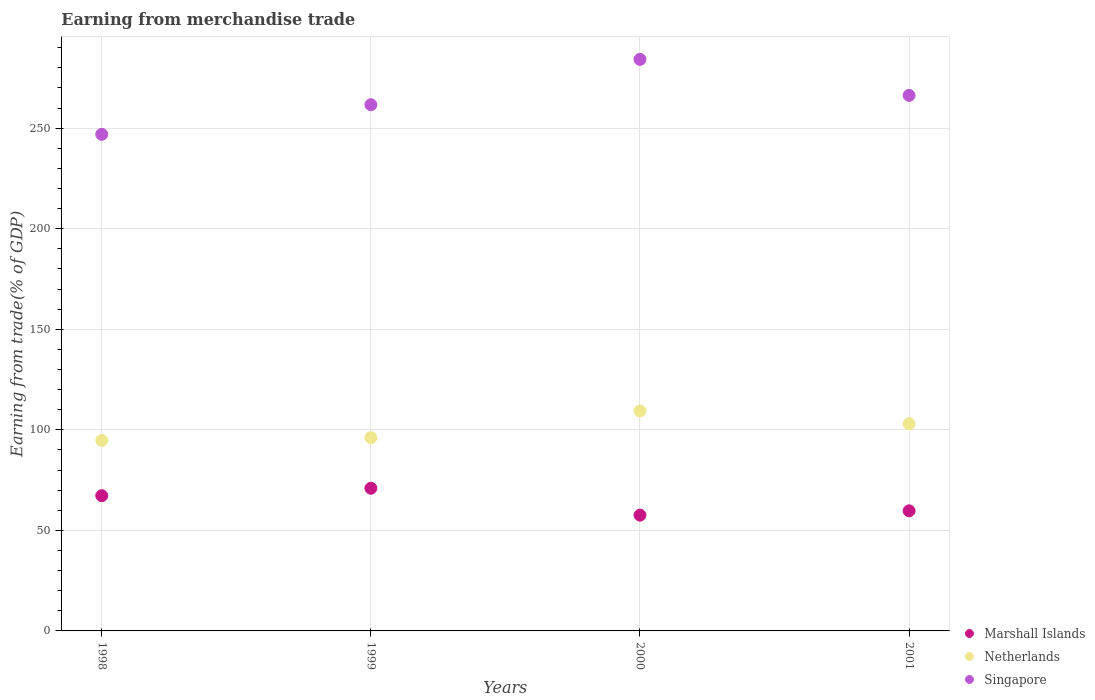How many different coloured dotlines are there?
Your response must be concise. 3. What is the earnings from trade in Marshall Islands in 2001?
Your answer should be very brief. 59.72. Across all years, what is the maximum earnings from trade in Marshall Islands?
Your answer should be compact. 70.94. Across all years, what is the minimum earnings from trade in Singapore?
Your response must be concise. 246.92. In which year was the earnings from trade in Netherlands maximum?
Provide a succinct answer. 2000. What is the total earnings from trade in Singapore in the graph?
Give a very brief answer. 1059.01. What is the difference between the earnings from trade in Marshall Islands in 1998 and that in 2000?
Offer a very short reply. 9.7. What is the difference between the earnings from trade in Netherlands in 1998 and the earnings from trade in Singapore in 2000?
Ensure brevity in your answer.  -189.47. What is the average earnings from trade in Netherlands per year?
Your answer should be very brief. 100.8. In the year 1999, what is the difference between the earnings from trade in Singapore and earnings from trade in Netherlands?
Provide a succinct answer. 165.53. In how many years, is the earnings from trade in Marshall Islands greater than 280 %?
Ensure brevity in your answer.  0. What is the ratio of the earnings from trade in Marshall Islands in 2000 to that in 2001?
Ensure brevity in your answer.  0.96. Is the earnings from trade in Netherlands in 1998 less than that in 1999?
Provide a succinct answer. Yes. What is the difference between the highest and the second highest earnings from trade in Singapore?
Offer a very short reply. 17.91. What is the difference between the highest and the lowest earnings from trade in Marshall Islands?
Make the answer very short. 13.38. In how many years, is the earnings from trade in Marshall Islands greater than the average earnings from trade in Marshall Islands taken over all years?
Your response must be concise. 2. Is the earnings from trade in Marshall Islands strictly greater than the earnings from trade in Singapore over the years?
Make the answer very short. No. How many dotlines are there?
Offer a very short reply. 3. How many years are there in the graph?
Give a very brief answer. 4. What is the difference between two consecutive major ticks on the Y-axis?
Keep it short and to the point. 50. Are the values on the major ticks of Y-axis written in scientific E-notation?
Ensure brevity in your answer.  No. Does the graph contain any zero values?
Provide a succinct answer. No. Where does the legend appear in the graph?
Offer a very short reply. Bottom right. How many legend labels are there?
Keep it short and to the point. 3. How are the legend labels stacked?
Give a very brief answer. Vertical. What is the title of the graph?
Offer a very short reply. Earning from merchandise trade. Does "Iceland" appear as one of the legend labels in the graph?
Offer a terse response. No. What is the label or title of the X-axis?
Ensure brevity in your answer.  Years. What is the label or title of the Y-axis?
Offer a terse response. Earning from trade(% of GDP). What is the Earning from trade(% of GDP) in Marshall Islands in 1998?
Make the answer very short. 67.25. What is the Earning from trade(% of GDP) of Netherlands in 1998?
Offer a very short reply. 94.71. What is the Earning from trade(% of GDP) in Singapore in 1998?
Make the answer very short. 246.92. What is the Earning from trade(% of GDP) of Marshall Islands in 1999?
Give a very brief answer. 70.94. What is the Earning from trade(% of GDP) of Netherlands in 1999?
Make the answer very short. 96.1. What is the Earning from trade(% of GDP) of Singapore in 1999?
Provide a succinct answer. 261.63. What is the Earning from trade(% of GDP) in Marshall Islands in 2000?
Make the answer very short. 57.55. What is the Earning from trade(% of GDP) of Netherlands in 2000?
Your answer should be compact. 109.35. What is the Earning from trade(% of GDP) in Singapore in 2000?
Offer a terse response. 284.19. What is the Earning from trade(% of GDP) in Marshall Islands in 2001?
Provide a succinct answer. 59.72. What is the Earning from trade(% of GDP) in Netherlands in 2001?
Keep it short and to the point. 103.03. What is the Earning from trade(% of GDP) of Singapore in 2001?
Provide a succinct answer. 266.28. Across all years, what is the maximum Earning from trade(% of GDP) in Marshall Islands?
Keep it short and to the point. 70.94. Across all years, what is the maximum Earning from trade(% of GDP) in Netherlands?
Provide a short and direct response. 109.35. Across all years, what is the maximum Earning from trade(% of GDP) in Singapore?
Your response must be concise. 284.19. Across all years, what is the minimum Earning from trade(% of GDP) of Marshall Islands?
Make the answer very short. 57.55. Across all years, what is the minimum Earning from trade(% of GDP) in Netherlands?
Make the answer very short. 94.71. Across all years, what is the minimum Earning from trade(% of GDP) in Singapore?
Offer a terse response. 246.92. What is the total Earning from trade(% of GDP) in Marshall Islands in the graph?
Give a very brief answer. 255.46. What is the total Earning from trade(% of GDP) of Netherlands in the graph?
Offer a terse response. 403.19. What is the total Earning from trade(% of GDP) in Singapore in the graph?
Give a very brief answer. 1059.01. What is the difference between the Earning from trade(% of GDP) in Marshall Islands in 1998 and that in 1999?
Ensure brevity in your answer.  -3.69. What is the difference between the Earning from trade(% of GDP) in Netherlands in 1998 and that in 1999?
Make the answer very short. -1.39. What is the difference between the Earning from trade(% of GDP) in Singapore in 1998 and that in 1999?
Your answer should be compact. -14.71. What is the difference between the Earning from trade(% of GDP) of Marshall Islands in 1998 and that in 2000?
Make the answer very short. 9.7. What is the difference between the Earning from trade(% of GDP) of Netherlands in 1998 and that in 2000?
Provide a succinct answer. -14.63. What is the difference between the Earning from trade(% of GDP) of Singapore in 1998 and that in 2000?
Offer a very short reply. -37.27. What is the difference between the Earning from trade(% of GDP) of Marshall Islands in 1998 and that in 2001?
Provide a short and direct response. 7.53. What is the difference between the Earning from trade(% of GDP) in Netherlands in 1998 and that in 2001?
Keep it short and to the point. -8.31. What is the difference between the Earning from trade(% of GDP) in Singapore in 1998 and that in 2001?
Offer a very short reply. -19.36. What is the difference between the Earning from trade(% of GDP) in Marshall Islands in 1999 and that in 2000?
Your answer should be very brief. 13.38. What is the difference between the Earning from trade(% of GDP) in Netherlands in 1999 and that in 2000?
Keep it short and to the point. -13.25. What is the difference between the Earning from trade(% of GDP) in Singapore in 1999 and that in 2000?
Offer a terse response. -22.56. What is the difference between the Earning from trade(% of GDP) of Marshall Islands in 1999 and that in 2001?
Your answer should be very brief. 11.22. What is the difference between the Earning from trade(% of GDP) of Netherlands in 1999 and that in 2001?
Provide a succinct answer. -6.93. What is the difference between the Earning from trade(% of GDP) in Singapore in 1999 and that in 2001?
Ensure brevity in your answer.  -4.65. What is the difference between the Earning from trade(% of GDP) in Marshall Islands in 2000 and that in 2001?
Provide a succinct answer. -2.16. What is the difference between the Earning from trade(% of GDP) of Netherlands in 2000 and that in 2001?
Your answer should be compact. 6.32. What is the difference between the Earning from trade(% of GDP) in Singapore in 2000 and that in 2001?
Ensure brevity in your answer.  17.91. What is the difference between the Earning from trade(% of GDP) of Marshall Islands in 1998 and the Earning from trade(% of GDP) of Netherlands in 1999?
Offer a very short reply. -28.85. What is the difference between the Earning from trade(% of GDP) in Marshall Islands in 1998 and the Earning from trade(% of GDP) in Singapore in 1999?
Give a very brief answer. -194.38. What is the difference between the Earning from trade(% of GDP) in Netherlands in 1998 and the Earning from trade(% of GDP) in Singapore in 1999?
Give a very brief answer. -166.91. What is the difference between the Earning from trade(% of GDP) of Marshall Islands in 1998 and the Earning from trade(% of GDP) of Netherlands in 2000?
Offer a terse response. -42.1. What is the difference between the Earning from trade(% of GDP) of Marshall Islands in 1998 and the Earning from trade(% of GDP) of Singapore in 2000?
Offer a terse response. -216.94. What is the difference between the Earning from trade(% of GDP) in Netherlands in 1998 and the Earning from trade(% of GDP) in Singapore in 2000?
Keep it short and to the point. -189.47. What is the difference between the Earning from trade(% of GDP) of Marshall Islands in 1998 and the Earning from trade(% of GDP) of Netherlands in 2001?
Ensure brevity in your answer.  -35.78. What is the difference between the Earning from trade(% of GDP) in Marshall Islands in 1998 and the Earning from trade(% of GDP) in Singapore in 2001?
Provide a succinct answer. -199.03. What is the difference between the Earning from trade(% of GDP) in Netherlands in 1998 and the Earning from trade(% of GDP) in Singapore in 2001?
Your response must be concise. -171.57. What is the difference between the Earning from trade(% of GDP) of Marshall Islands in 1999 and the Earning from trade(% of GDP) of Netherlands in 2000?
Offer a very short reply. -38.41. What is the difference between the Earning from trade(% of GDP) of Marshall Islands in 1999 and the Earning from trade(% of GDP) of Singapore in 2000?
Provide a short and direct response. -213.25. What is the difference between the Earning from trade(% of GDP) in Netherlands in 1999 and the Earning from trade(% of GDP) in Singapore in 2000?
Ensure brevity in your answer.  -188.09. What is the difference between the Earning from trade(% of GDP) of Marshall Islands in 1999 and the Earning from trade(% of GDP) of Netherlands in 2001?
Offer a terse response. -32.09. What is the difference between the Earning from trade(% of GDP) in Marshall Islands in 1999 and the Earning from trade(% of GDP) in Singapore in 2001?
Ensure brevity in your answer.  -195.34. What is the difference between the Earning from trade(% of GDP) of Netherlands in 1999 and the Earning from trade(% of GDP) of Singapore in 2001?
Your answer should be compact. -170.18. What is the difference between the Earning from trade(% of GDP) in Marshall Islands in 2000 and the Earning from trade(% of GDP) in Netherlands in 2001?
Your response must be concise. -45.48. What is the difference between the Earning from trade(% of GDP) of Marshall Islands in 2000 and the Earning from trade(% of GDP) of Singapore in 2001?
Provide a succinct answer. -208.73. What is the difference between the Earning from trade(% of GDP) in Netherlands in 2000 and the Earning from trade(% of GDP) in Singapore in 2001?
Your answer should be compact. -156.93. What is the average Earning from trade(% of GDP) of Marshall Islands per year?
Ensure brevity in your answer.  63.86. What is the average Earning from trade(% of GDP) of Netherlands per year?
Offer a very short reply. 100.8. What is the average Earning from trade(% of GDP) in Singapore per year?
Give a very brief answer. 264.75. In the year 1998, what is the difference between the Earning from trade(% of GDP) in Marshall Islands and Earning from trade(% of GDP) in Netherlands?
Your answer should be very brief. -27.46. In the year 1998, what is the difference between the Earning from trade(% of GDP) in Marshall Islands and Earning from trade(% of GDP) in Singapore?
Offer a terse response. -179.67. In the year 1998, what is the difference between the Earning from trade(% of GDP) in Netherlands and Earning from trade(% of GDP) in Singapore?
Offer a very short reply. -152.2. In the year 1999, what is the difference between the Earning from trade(% of GDP) of Marshall Islands and Earning from trade(% of GDP) of Netherlands?
Give a very brief answer. -25.16. In the year 1999, what is the difference between the Earning from trade(% of GDP) in Marshall Islands and Earning from trade(% of GDP) in Singapore?
Provide a succinct answer. -190.69. In the year 1999, what is the difference between the Earning from trade(% of GDP) in Netherlands and Earning from trade(% of GDP) in Singapore?
Provide a succinct answer. -165.53. In the year 2000, what is the difference between the Earning from trade(% of GDP) in Marshall Islands and Earning from trade(% of GDP) in Netherlands?
Offer a terse response. -51.8. In the year 2000, what is the difference between the Earning from trade(% of GDP) in Marshall Islands and Earning from trade(% of GDP) in Singapore?
Your answer should be very brief. -226.64. In the year 2000, what is the difference between the Earning from trade(% of GDP) of Netherlands and Earning from trade(% of GDP) of Singapore?
Give a very brief answer. -174.84. In the year 2001, what is the difference between the Earning from trade(% of GDP) in Marshall Islands and Earning from trade(% of GDP) in Netherlands?
Provide a short and direct response. -43.31. In the year 2001, what is the difference between the Earning from trade(% of GDP) of Marshall Islands and Earning from trade(% of GDP) of Singapore?
Make the answer very short. -206.56. In the year 2001, what is the difference between the Earning from trade(% of GDP) in Netherlands and Earning from trade(% of GDP) in Singapore?
Offer a terse response. -163.25. What is the ratio of the Earning from trade(% of GDP) in Marshall Islands in 1998 to that in 1999?
Provide a succinct answer. 0.95. What is the ratio of the Earning from trade(% of GDP) of Netherlands in 1998 to that in 1999?
Give a very brief answer. 0.99. What is the ratio of the Earning from trade(% of GDP) of Singapore in 1998 to that in 1999?
Make the answer very short. 0.94. What is the ratio of the Earning from trade(% of GDP) of Marshall Islands in 1998 to that in 2000?
Your answer should be compact. 1.17. What is the ratio of the Earning from trade(% of GDP) of Netherlands in 1998 to that in 2000?
Give a very brief answer. 0.87. What is the ratio of the Earning from trade(% of GDP) in Singapore in 1998 to that in 2000?
Your answer should be compact. 0.87. What is the ratio of the Earning from trade(% of GDP) in Marshall Islands in 1998 to that in 2001?
Your answer should be very brief. 1.13. What is the ratio of the Earning from trade(% of GDP) in Netherlands in 1998 to that in 2001?
Give a very brief answer. 0.92. What is the ratio of the Earning from trade(% of GDP) of Singapore in 1998 to that in 2001?
Provide a succinct answer. 0.93. What is the ratio of the Earning from trade(% of GDP) of Marshall Islands in 1999 to that in 2000?
Make the answer very short. 1.23. What is the ratio of the Earning from trade(% of GDP) of Netherlands in 1999 to that in 2000?
Your answer should be compact. 0.88. What is the ratio of the Earning from trade(% of GDP) in Singapore in 1999 to that in 2000?
Provide a short and direct response. 0.92. What is the ratio of the Earning from trade(% of GDP) of Marshall Islands in 1999 to that in 2001?
Your answer should be compact. 1.19. What is the ratio of the Earning from trade(% of GDP) in Netherlands in 1999 to that in 2001?
Make the answer very short. 0.93. What is the ratio of the Earning from trade(% of GDP) of Singapore in 1999 to that in 2001?
Provide a succinct answer. 0.98. What is the ratio of the Earning from trade(% of GDP) of Marshall Islands in 2000 to that in 2001?
Your response must be concise. 0.96. What is the ratio of the Earning from trade(% of GDP) of Netherlands in 2000 to that in 2001?
Offer a terse response. 1.06. What is the ratio of the Earning from trade(% of GDP) of Singapore in 2000 to that in 2001?
Offer a terse response. 1.07. What is the difference between the highest and the second highest Earning from trade(% of GDP) of Marshall Islands?
Your answer should be compact. 3.69. What is the difference between the highest and the second highest Earning from trade(% of GDP) of Netherlands?
Make the answer very short. 6.32. What is the difference between the highest and the second highest Earning from trade(% of GDP) of Singapore?
Give a very brief answer. 17.91. What is the difference between the highest and the lowest Earning from trade(% of GDP) in Marshall Islands?
Make the answer very short. 13.38. What is the difference between the highest and the lowest Earning from trade(% of GDP) of Netherlands?
Keep it short and to the point. 14.63. What is the difference between the highest and the lowest Earning from trade(% of GDP) in Singapore?
Your response must be concise. 37.27. 